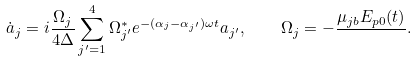Convert formula to latex. <formula><loc_0><loc_0><loc_500><loc_500>\dot { a } _ { j } = i \frac { \Omega _ { j } } { 4 \Delta } \sum _ { j ^ { \prime } = 1 } ^ { 4 } \Omega _ { j ^ { \prime } } ^ { * } e ^ { - ( \alpha _ { j } - \alpha _ { j ^ { \prime } } ) \omega t } a _ { j ^ { \prime } } , \quad \Omega _ { j } = - \frac { \mu _ { j b } E _ { p 0 } ( t ) } { } .</formula> 